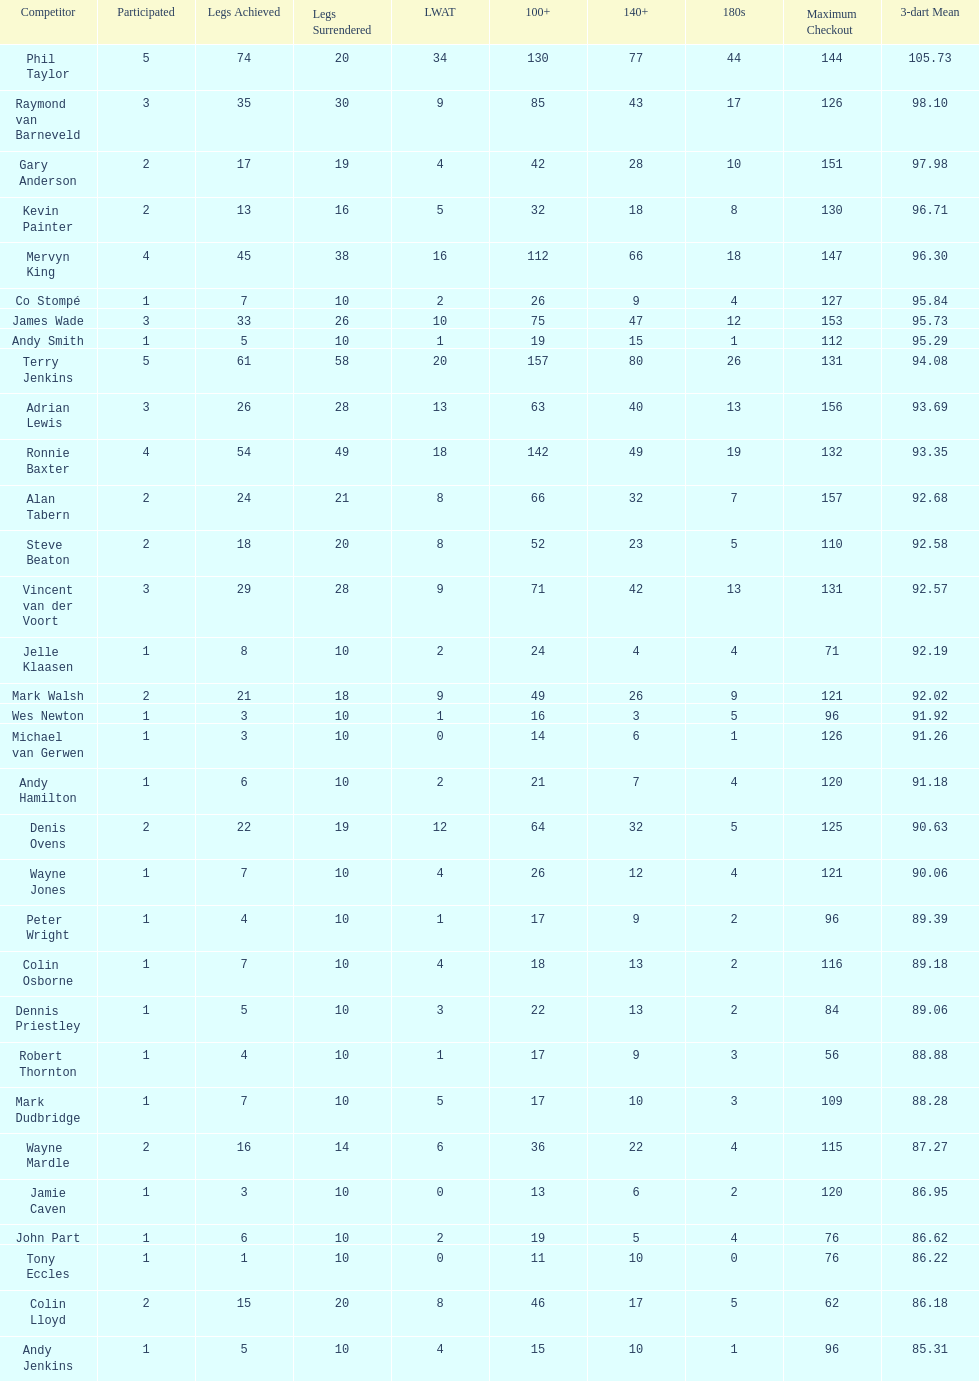Which player has his high checkout as 116? Colin Osborne. 